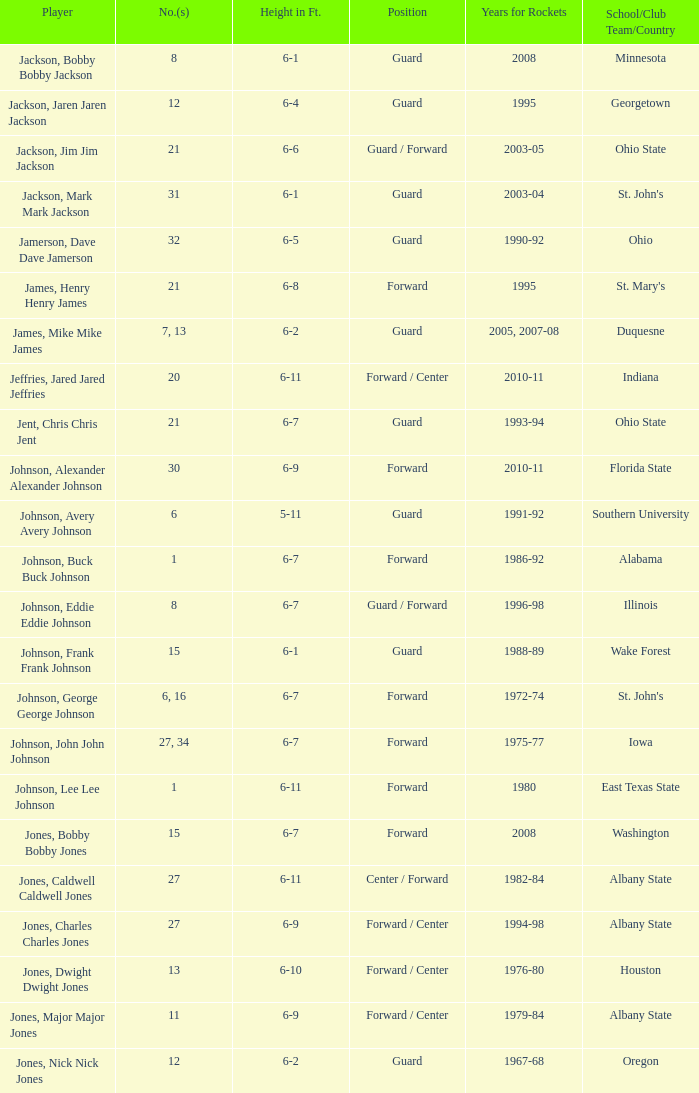What is the quantity of the athlete who attended southern university? 6.0. 